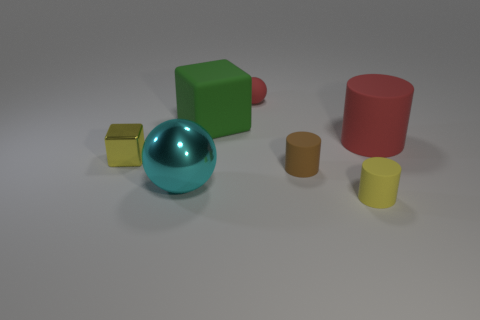Add 1 small red objects. How many objects exist? 8 Subtract all cylinders. How many objects are left? 4 Add 5 small red matte objects. How many small red matte objects are left? 6 Add 6 small cyan rubber cubes. How many small cyan rubber cubes exist? 6 Subtract 1 green blocks. How many objects are left? 6 Subtract all big green cubes. Subtract all tiny matte balls. How many objects are left? 5 